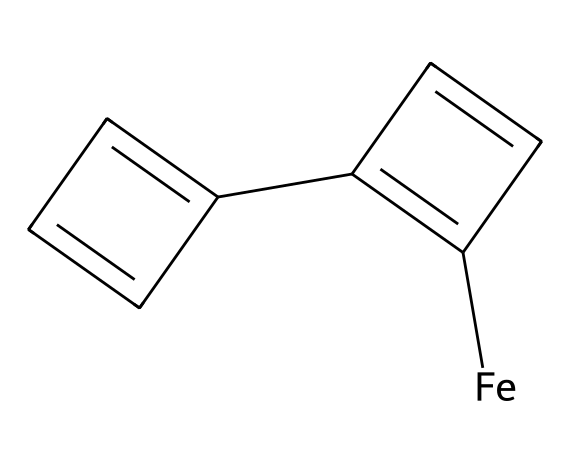What is the central metal in this ferrocene structure? The central part of the molecule is a metal atom. In the SMILES representation, "[Fe]" indicates the presence of iron as the central metal.
Answer: iron How many aromatic rings are present in ferrocene? The molecule has two distinct parts around the iron, each shown as "C1=C(C=C1)" and "C2=CC=C2" in the SMILES representation, which indicates the presence of two aromatic rings.
Answer: two What type of bonding can be inferred from the metal-aryl interactions in ferrocene? Ferrocene features sandwich-like architecture where the iron interacts with two aromatic cyclopentadienyl rings. This indicates a type of bonding known as σ-bonding or coordinate covalent bonding.
Answer: sigma-bonding What is the molecular formula of ferrocene? By analyzing the SMILES structure, we can deduce the number of carbon (C) and hydrogen (H) atoms alongside the iron (Fe). Ferrocene consists of five carbon atoms from each cyclopentadienyl (totaling ten) and five hydrogen atoms, leading to the molecular formula C10H10Fe.
Answer: C10H10Fe What functional groups does ferrocene contain? The SMILES representation highlights that ferrocene contains cyclopentadienyl groups, which can be classified as aryl (due to the aromatic nature), but there are no other functional groups such as hydroxyl or carboxyl.
Answer: aryl Is ferrocene considered a stable organometallic compound? Based on the structural features of ferrocene, particularly the stable sandwich structure, it is widely recognized in chemistry as a stable organometallic compound.
Answer: stable What is the role of ferrocene in fuel additives? Ferrocene is known for its ability to enhance combustion efficiency in fuels, thus serving as a combustion additive to improve octane ratings.
Answer: combustion additive 